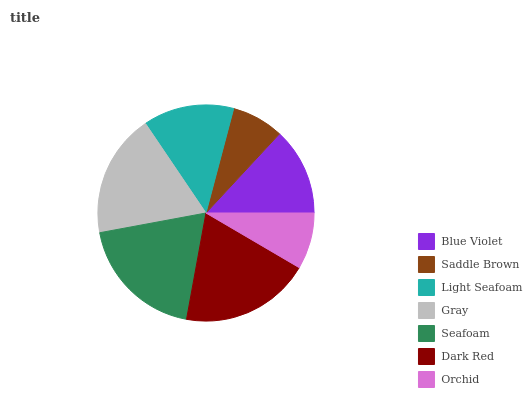Is Saddle Brown the minimum?
Answer yes or no. Yes. Is Dark Red the maximum?
Answer yes or no. Yes. Is Light Seafoam the minimum?
Answer yes or no. No. Is Light Seafoam the maximum?
Answer yes or no. No. Is Light Seafoam greater than Saddle Brown?
Answer yes or no. Yes. Is Saddle Brown less than Light Seafoam?
Answer yes or no. Yes. Is Saddle Brown greater than Light Seafoam?
Answer yes or no. No. Is Light Seafoam less than Saddle Brown?
Answer yes or no. No. Is Light Seafoam the high median?
Answer yes or no. Yes. Is Light Seafoam the low median?
Answer yes or no. Yes. Is Blue Violet the high median?
Answer yes or no. No. Is Blue Violet the low median?
Answer yes or no. No. 